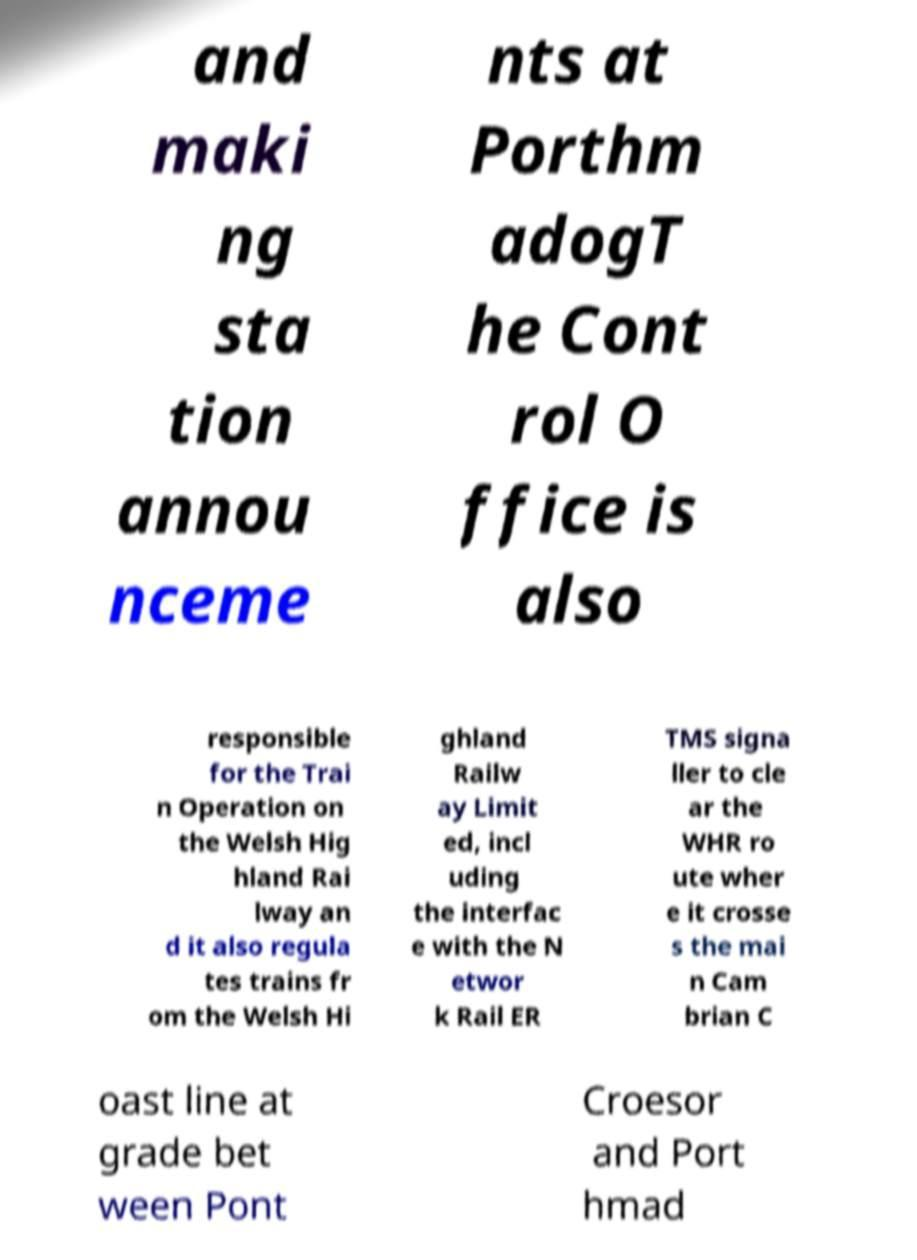What messages or text are displayed in this image? I need them in a readable, typed format. and maki ng sta tion annou nceme nts at Porthm adogT he Cont rol O ffice is also responsible for the Trai n Operation on the Welsh Hig hland Rai lway an d it also regula tes trains fr om the Welsh Hi ghland Railw ay Limit ed, incl uding the interfac e with the N etwor k Rail ER TMS signa ller to cle ar the WHR ro ute wher e it crosse s the mai n Cam brian C oast line at grade bet ween Pont Croesor and Port hmad 